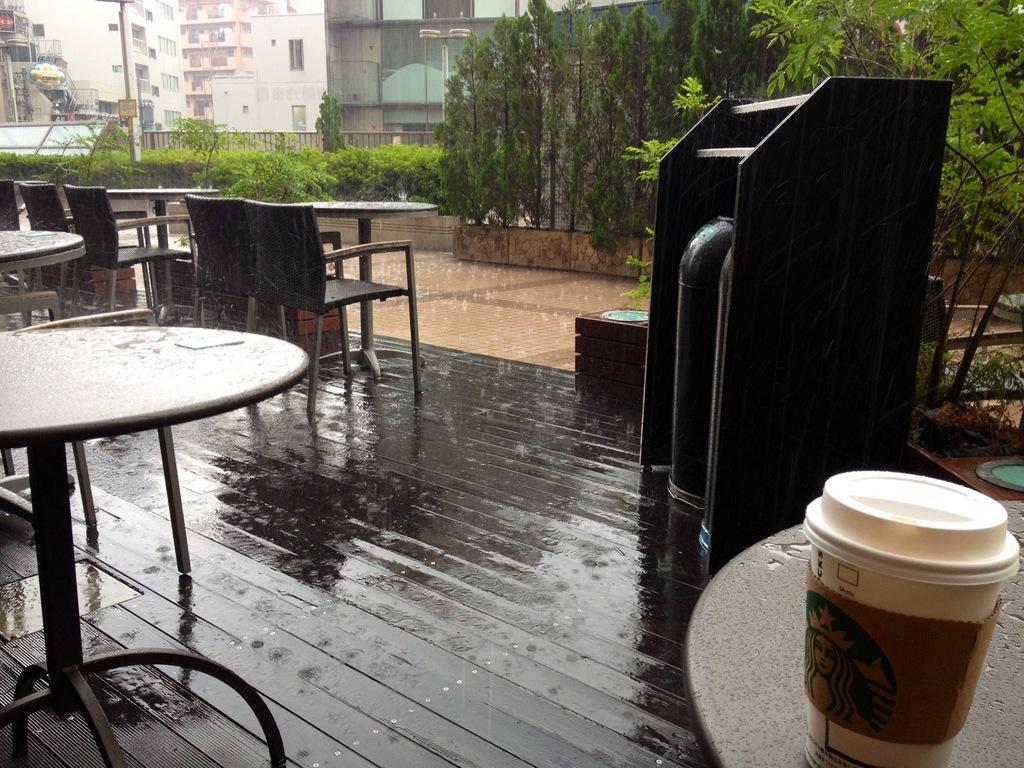Can you describe this image briefly? In this picture there are many unoccupied tables ,chairs kept outside which are in rain. To the right side of the we can observe a starbucks coffee cup. In the background there are many trees and buildings. 